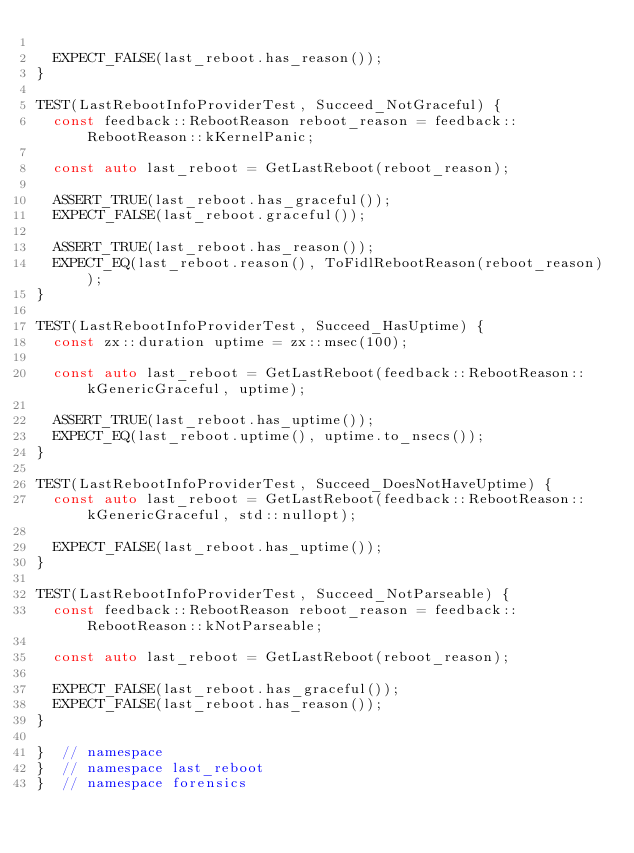Convert code to text. <code><loc_0><loc_0><loc_500><loc_500><_C++_>
  EXPECT_FALSE(last_reboot.has_reason());
}

TEST(LastRebootInfoProviderTest, Succeed_NotGraceful) {
  const feedback::RebootReason reboot_reason = feedback::RebootReason::kKernelPanic;

  const auto last_reboot = GetLastReboot(reboot_reason);

  ASSERT_TRUE(last_reboot.has_graceful());
  EXPECT_FALSE(last_reboot.graceful());

  ASSERT_TRUE(last_reboot.has_reason());
  EXPECT_EQ(last_reboot.reason(), ToFidlRebootReason(reboot_reason));
}

TEST(LastRebootInfoProviderTest, Succeed_HasUptime) {
  const zx::duration uptime = zx::msec(100);

  const auto last_reboot = GetLastReboot(feedback::RebootReason::kGenericGraceful, uptime);

  ASSERT_TRUE(last_reboot.has_uptime());
  EXPECT_EQ(last_reboot.uptime(), uptime.to_nsecs());
}

TEST(LastRebootInfoProviderTest, Succeed_DoesNotHaveUptime) {
  const auto last_reboot = GetLastReboot(feedback::RebootReason::kGenericGraceful, std::nullopt);

  EXPECT_FALSE(last_reboot.has_uptime());
}

TEST(LastRebootInfoProviderTest, Succeed_NotParseable) {
  const feedback::RebootReason reboot_reason = feedback::RebootReason::kNotParseable;

  const auto last_reboot = GetLastReboot(reboot_reason);

  EXPECT_FALSE(last_reboot.has_graceful());
  EXPECT_FALSE(last_reboot.has_reason());
}

}  // namespace
}  // namespace last_reboot
}  // namespace forensics
</code> 